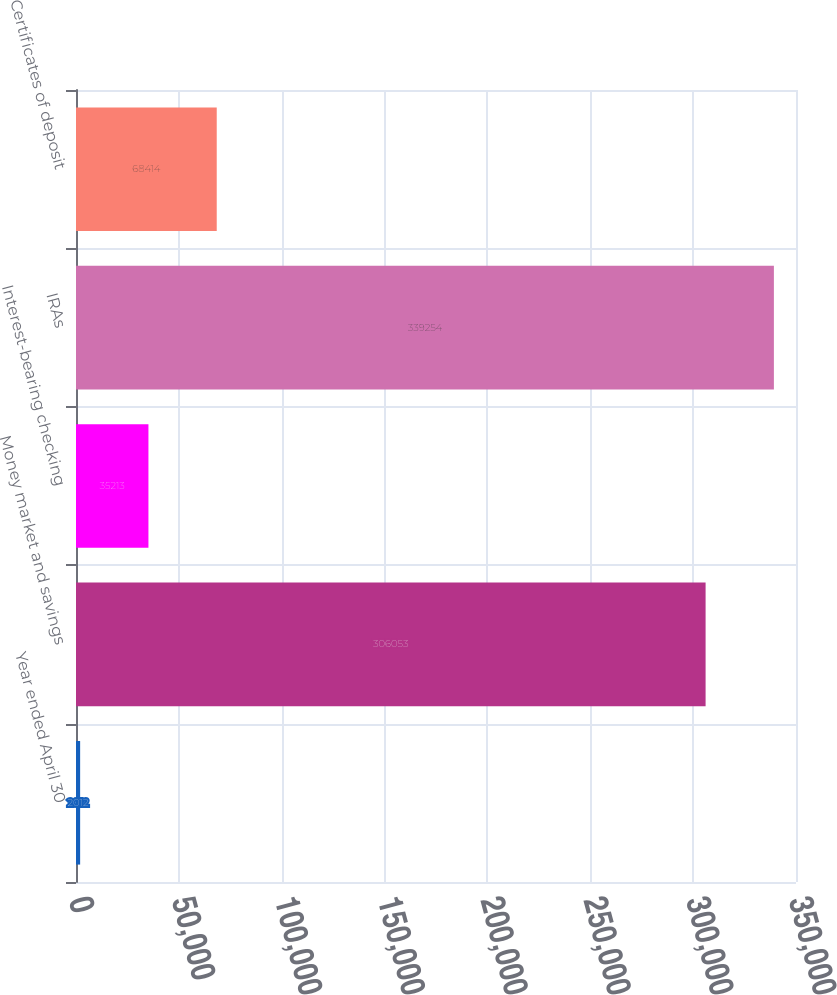Convert chart to OTSL. <chart><loc_0><loc_0><loc_500><loc_500><bar_chart><fcel>Year ended April 30<fcel>Money market and savings<fcel>Interest-bearing checking<fcel>IRAs<fcel>Certificates of deposit<nl><fcel>2012<fcel>306053<fcel>35213<fcel>339254<fcel>68414<nl></chart> 